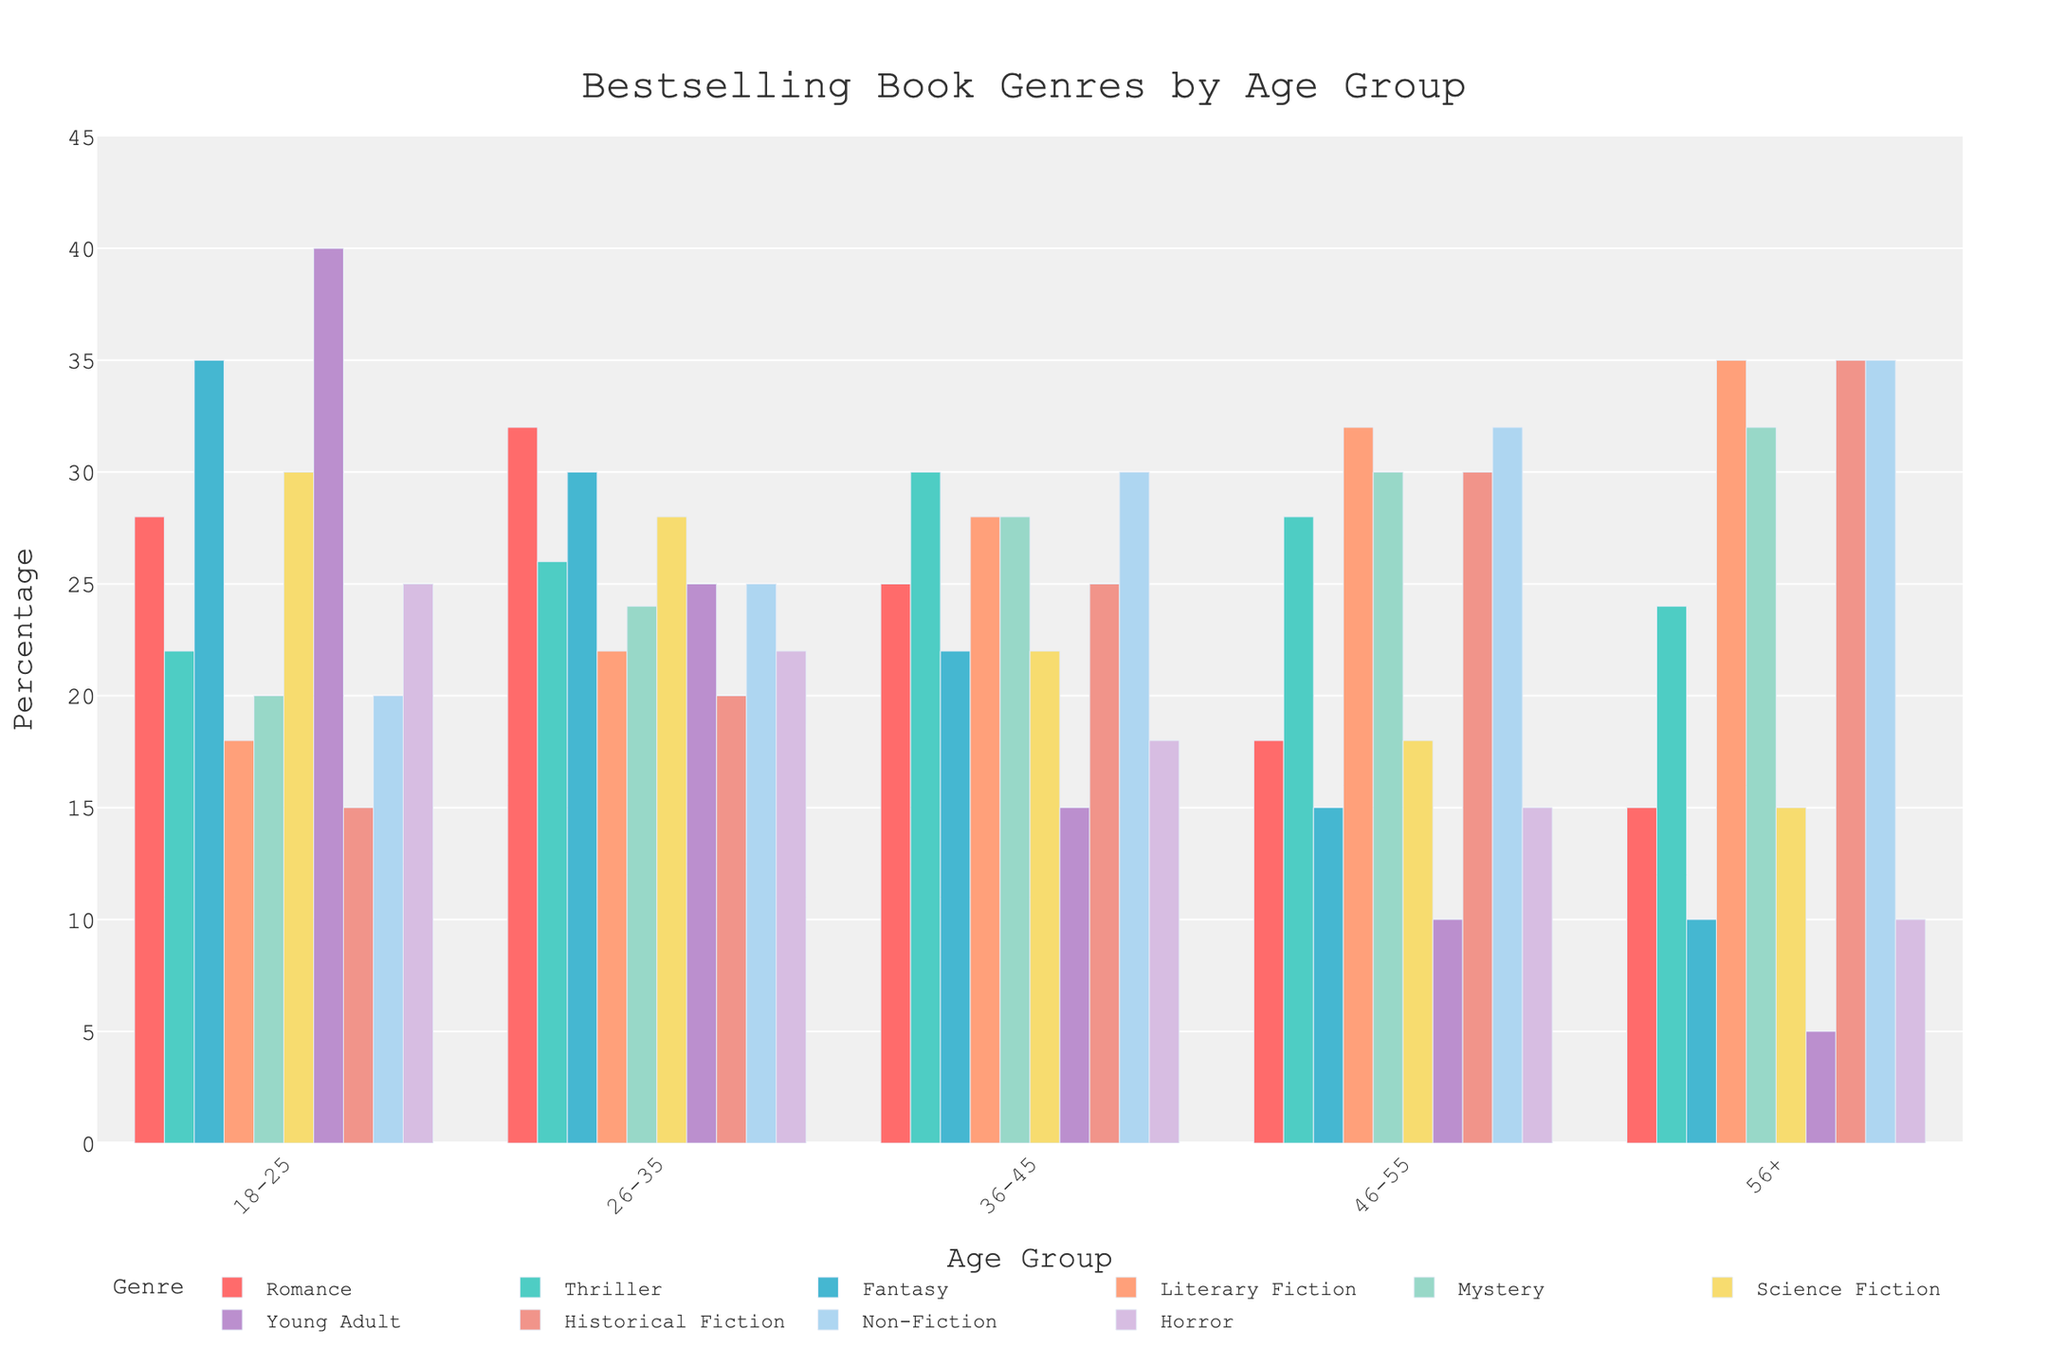Which genre is the most popular among the 18-25 age group? When looking at the bars for the 18-25 age group, the highest bar corresponds to the "Young Adult" genre with a 40% share.
Answer: Young Adult Which genre is preferred by the 46-55 age group? For the 46-55 age group, the highest percentage is for "Literary Fiction," shown by the tallest bar at 32%.
Answer: Literary Fiction How does the preference for Fantasy change across the age groups? Observe the heights of the Fantasy bars: 35% (18-25), 30% (26-35), 22% (36-45), 15% (46-55), 10% (56+). It consistently decreases as age increases.
Answer: Decreases What is the average percentage of Thriller readers across all age groups? Sum the percentages for Thriller: 22% + 26% + 30% + 28% + 24% = 130%. Then divide by 5 for the number of age groups. 130 / 5 = 26%.
Answer: 26% In which age group is Mystery the least popular? By examining the bars for Mystery, the lowest percentage is 20% in the 18-25 age group.
Answer: 18-25 Which age group has the highest percentage of readers for Historical Fiction? The tallest bar for Historical Fiction is in the 56+ age group, with a percentage of 35%.
Answer: 56+ Is the percentage of Non-Fiction readers higher in the 26-35 group or the 46-55 group? For Non-Fiction readers, the percentages are 25% in the 26-35 group and 32% in the 46-55 group. 32% is higher than 25%.
Answer: 46-55 Which genre has an equal percentage of readers for both the 26-35 and 36-45 age groups? For Romance: 32% (26-35) vs 25% (36-45); Thriller: 26% (26-35) vs 30% (36-45); Fantasy: 30% (26-35) vs 22% (36-45); Literary Fiction: 22% (26-35) vs 28% (36-45); Mystery: 24% (26-35) vs 28% (36-45); Science Fiction: 28% (26-35) vs 22% (36-45); Young Adult: 25% (26-35) vs 15% (36-45); Historical Fiction: 20% (26-35) vs 25% (36-45); Non-Fiction: 25% (26-35) vs 30% (36-45); Horror: 22% (26-35) vs 18% (36-45). No genre matches.
Answer: None Do any genres have a consistent downward trend across all age groups? Examine each genre across all age groups: Romance decreases, Thriller varies, Fantasy decreases, Literary Fiction increases, Mystery increases, Science Fiction decreases, Young Adult decreases, Historical Fiction increases, Non-Fiction increases, Horror decreases. Romance, Fantasy, Science Fiction, Young Adult, and Horror show consistent downward trends.
Answer: Romance, Fantasy, Science Fiction, Young Adult, Horror Which genre shows the least variation in preference across age groups? Calculate the range (max - min) of preferences for each genre: Romance (32-15=17), Thriller (30-22=8), Fantasy (35-10=25), Literary Fiction (35-18=17), Mystery (32-20=12), Science Fiction (30-15=15), Young Adult (40-5=35), Historical Fiction (35-15=20), Non-Fiction (35-20=15), Horror (25-10=15). Thriller shows the least variation with a range of 8.
Answer: Thriller 